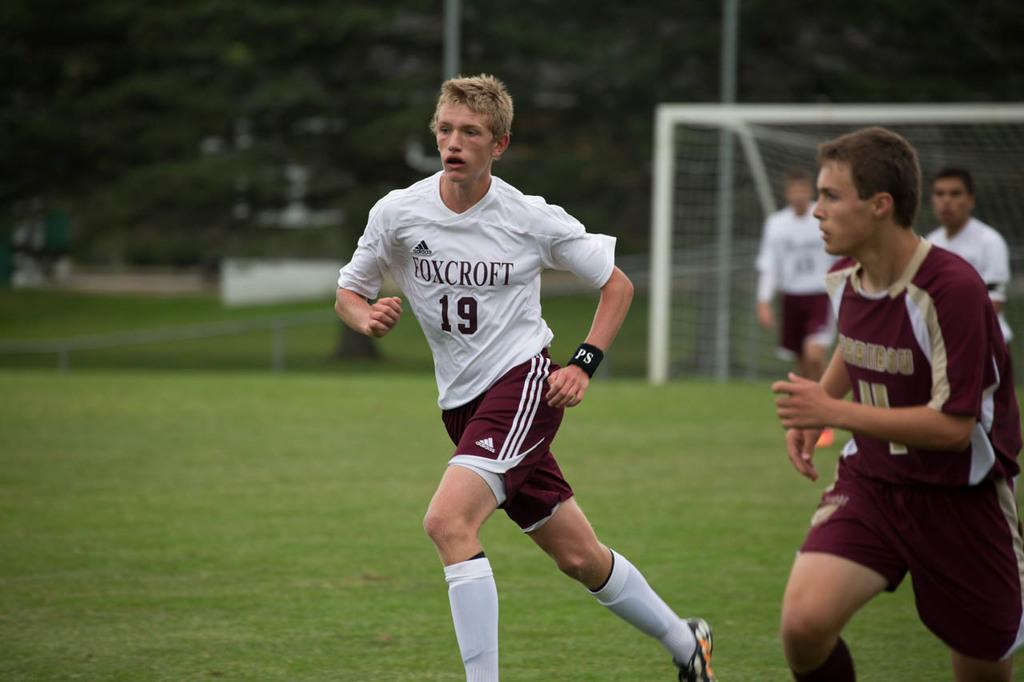<image>
Offer a succinct explanation of the picture presented. a jersey that has the number 19 on it 